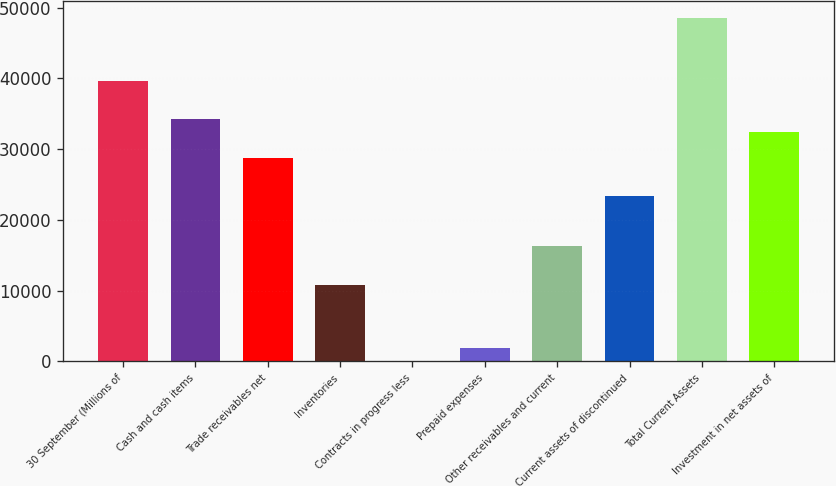Convert chart. <chart><loc_0><loc_0><loc_500><loc_500><bar_chart><fcel>30 September (Millions of<fcel>Cash and cash items<fcel>Trade receivables net<fcel>Inventories<fcel>Contracts in progress less<fcel>Prepaid expenses<fcel>Other receivables and current<fcel>Current assets of discontinued<fcel>Total Current Assets<fcel>Investment in net assets of<nl><fcel>39585.4<fcel>34196.2<fcel>28807<fcel>10843<fcel>64.6<fcel>1861<fcel>16232.2<fcel>23417.8<fcel>48567.4<fcel>32399.8<nl></chart> 